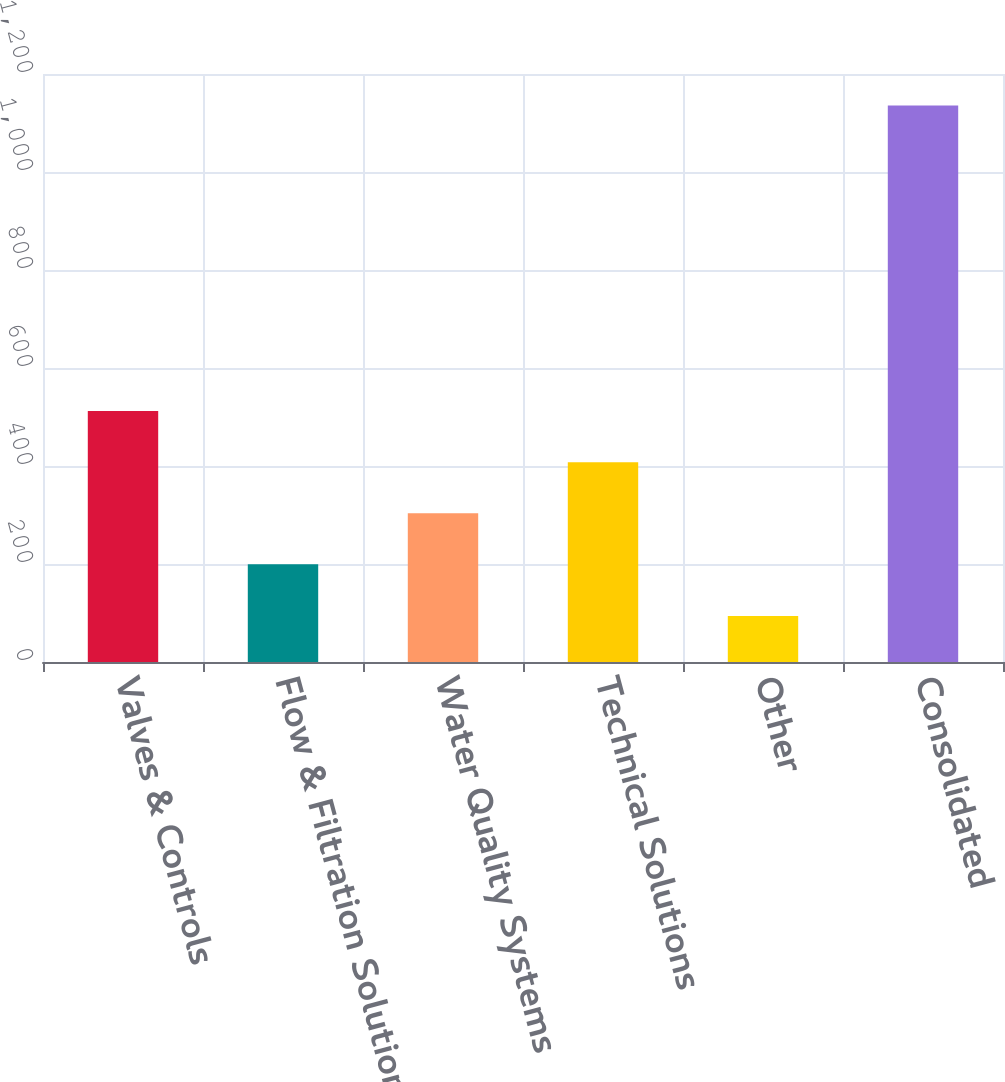<chart> <loc_0><loc_0><loc_500><loc_500><bar_chart><fcel>Valves & Controls<fcel>Flow & Filtration Solutions<fcel>Water Quality Systems<fcel>Technical Solutions<fcel>Other<fcel>Consolidated<nl><fcel>512.1<fcel>199.5<fcel>303.7<fcel>407.9<fcel>93.7<fcel>1135.7<nl></chart> 